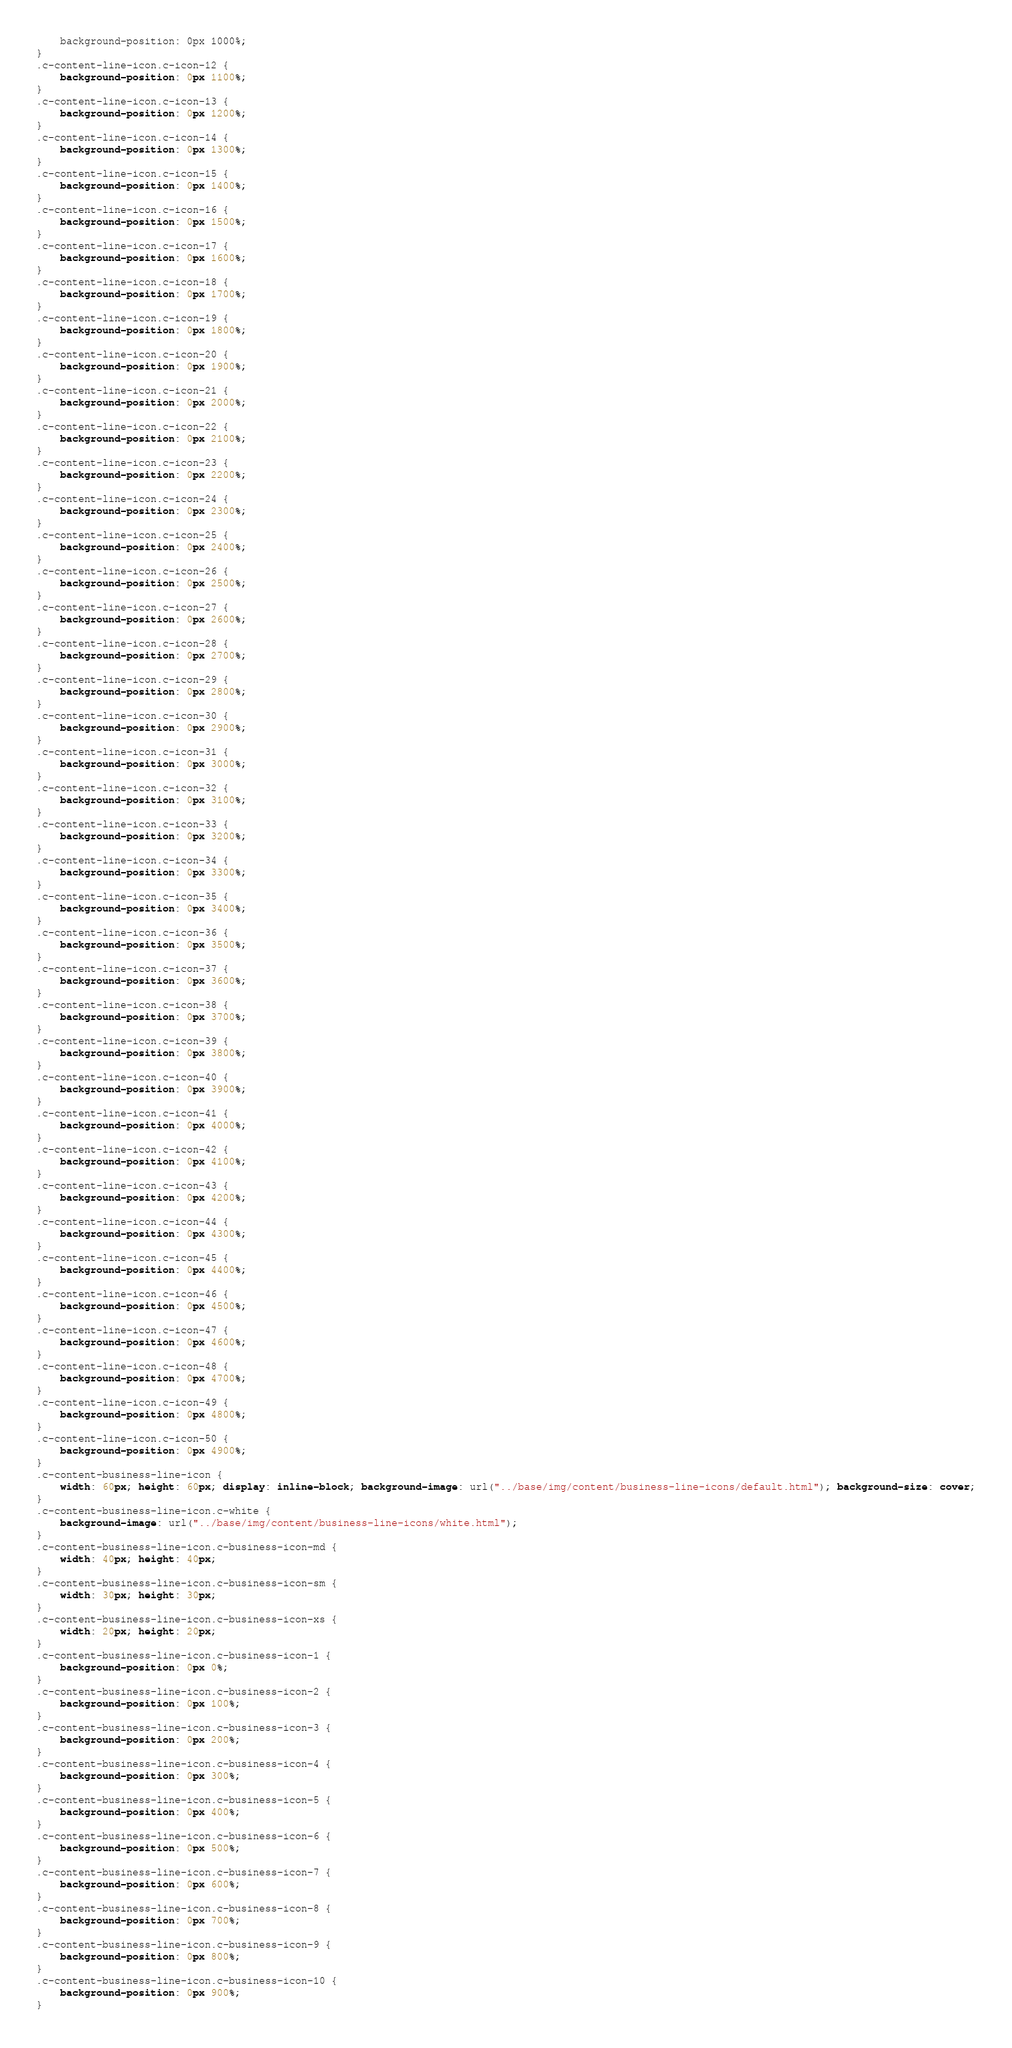<code> <loc_0><loc_0><loc_500><loc_500><_CSS_>    background-position: 0px 1000%;
}
.c-content-line-icon.c-icon-12 {
    background-position: 0px 1100%;
}
.c-content-line-icon.c-icon-13 {
    background-position: 0px 1200%;
}
.c-content-line-icon.c-icon-14 {
    background-position: 0px 1300%;
}
.c-content-line-icon.c-icon-15 {
    background-position: 0px 1400%;
}
.c-content-line-icon.c-icon-16 {
    background-position: 0px 1500%;
}
.c-content-line-icon.c-icon-17 {
    background-position: 0px 1600%;
}
.c-content-line-icon.c-icon-18 {
    background-position: 0px 1700%;
}
.c-content-line-icon.c-icon-19 {
    background-position: 0px 1800%;
}
.c-content-line-icon.c-icon-20 {
    background-position: 0px 1900%;
}
.c-content-line-icon.c-icon-21 {
    background-position: 0px 2000%;
}
.c-content-line-icon.c-icon-22 {
    background-position: 0px 2100%;
}
.c-content-line-icon.c-icon-23 {
    background-position: 0px 2200%;
}
.c-content-line-icon.c-icon-24 {
    background-position: 0px 2300%;
}
.c-content-line-icon.c-icon-25 {
    background-position: 0px 2400%;
}
.c-content-line-icon.c-icon-26 {
    background-position: 0px 2500%;
}
.c-content-line-icon.c-icon-27 {
    background-position: 0px 2600%;
}
.c-content-line-icon.c-icon-28 {
    background-position: 0px 2700%;
}
.c-content-line-icon.c-icon-29 {
    background-position: 0px 2800%;
}
.c-content-line-icon.c-icon-30 {
    background-position: 0px 2900%;
}
.c-content-line-icon.c-icon-31 {
    background-position: 0px 3000%;
}
.c-content-line-icon.c-icon-32 {
    background-position: 0px 3100%;
}
.c-content-line-icon.c-icon-33 {
    background-position: 0px 3200%;
}
.c-content-line-icon.c-icon-34 {
    background-position: 0px 3300%;
}
.c-content-line-icon.c-icon-35 {
    background-position: 0px 3400%;
}
.c-content-line-icon.c-icon-36 {
    background-position: 0px 3500%;
}
.c-content-line-icon.c-icon-37 {
    background-position: 0px 3600%;
}
.c-content-line-icon.c-icon-38 {
    background-position: 0px 3700%;
}
.c-content-line-icon.c-icon-39 {
    background-position: 0px 3800%;
}
.c-content-line-icon.c-icon-40 {
    background-position: 0px 3900%;
}
.c-content-line-icon.c-icon-41 {
    background-position: 0px 4000%;
}
.c-content-line-icon.c-icon-42 {
    background-position: 0px 4100%;
}
.c-content-line-icon.c-icon-43 {
    background-position: 0px 4200%;
}
.c-content-line-icon.c-icon-44 {
    background-position: 0px 4300%;
}
.c-content-line-icon.c-icon-45 {
    background-position: 0px 4400%;
}
.c-content-line-icon.c-icon-46 {
    background-position: 0px 4500%;
}
.c-content-line-icon.c-icon-47 {
    background-position: 0px 4600%;
}
.c-content-line-icon.c-icon-48 {
    background-position: 0px 4700%;
}
.c-content-line-icon.c-icon-49 {
    background-position: 0px 4800%;
}
.c-content-line-icon.c-icon-50 {
    background-position: 0px 4900%;
}
.c-content-business-line-icon {
    width: 60px; height: 60px; display: inline-block; background-image: url("../base/img/content/business-line-icons/default.html"); background-size: cover;
}
.c-content-business-line-icon.c-white {
    background-image: url("../base/img/content/business-line-icons/white.html");
}
.c-content-business-line-icon.c-business-icon-md {
    width: 40px; height: 40px;
}
.c-content-business-line-icon.c-business-icon-sm {
    width: 30px; height: 30px;
}
.c-content-business-line-icon.c-business-icon-xs {
    width: 20px; height: 20px;
}
.c-content-business-line-icon.c-business-icon-1 {
    background-position: 0px 0%;
}
.c-content-business-line-icon.c-business-icon-2 {
    background-position: 0px 100%;
}
.c-content-business-line-icon.c-business-icon-3 {
    background-position: 0px 200%;
}
.c-content-business-line-icon.c-business-icon-4 {
    background-position: 0px 300%;
}
.c-content-business-line-icon.c-business-icon-5 {
    background-position: 0px 400%;
}
.c-content-business-line-icon.c-business-icon-6 {
    background-position: 0px 500%;
}
.c-content-business-line-icon.c-business-icon-7 {
    background-position: 0px 600%;
}
.c-content-business-line-icon.c-business-icon-8 {
    background-position: 0px 700%;
}
.c-content-business-line-icon.c-business-icon-9 {
    background-position: 0px 800%;
}
.c-content-business-line-icon.c-business-icon-10 {
    background-position: 0px 900%;
}</code> 